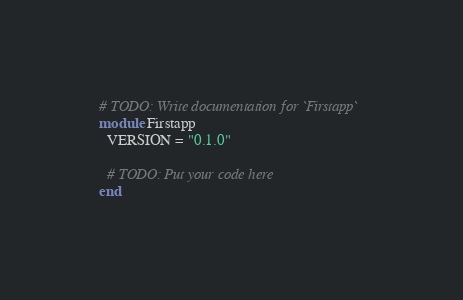<code> <loc_0><loc_0><loc_500><loc_500><_Crystal_># TODO: Write documentation for `Firstapp`
module Firstapp
  VERSION = "0.1.0"

  # TODO: Put your code here
end
</code> 